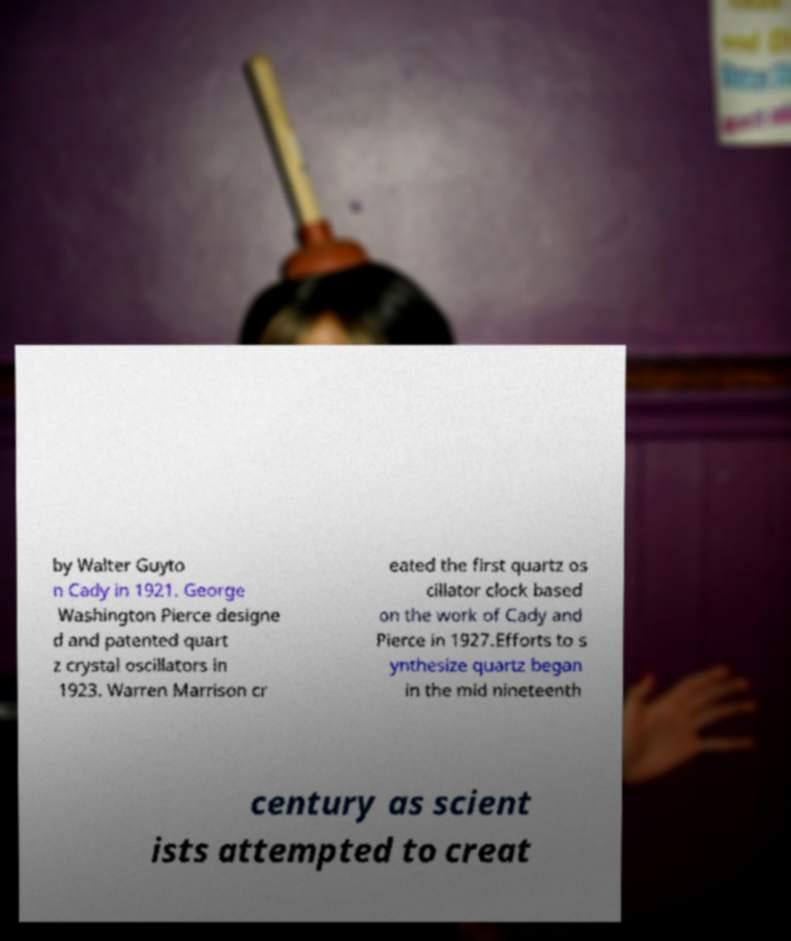Please identify and transcribe the text found in this image. by Walter Guyto n Cady in 1921. George Washington Pierce designe d and patented quart z crystal oscillators in 1923. Warren Marrison cr eated the first quartz os cillator clock based on the work of Cady and Pierce in 1927.Efforts to s ynthesize quartz began in the mid nineteenth century as scient ists attempted to creat 